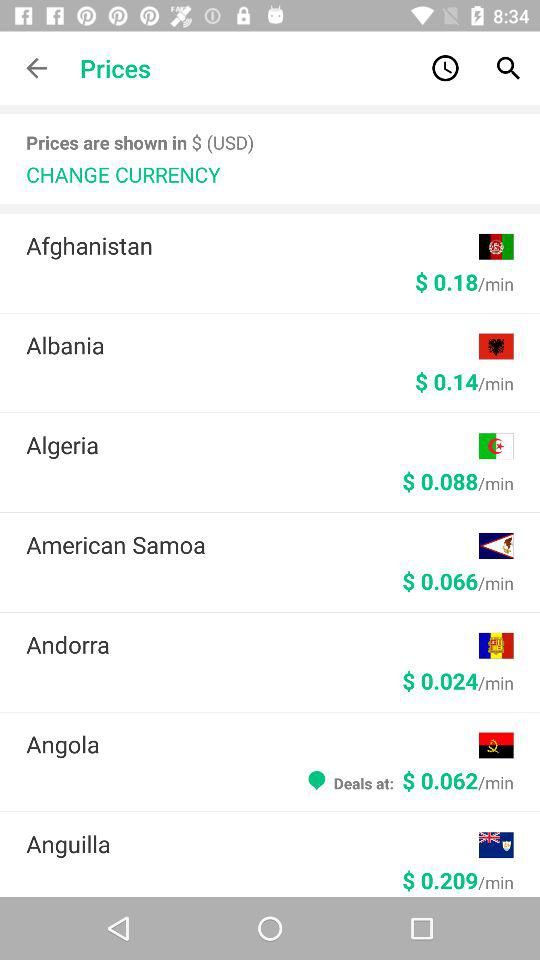How much does Algeria cost per minute?
Answer the question using a single word or phrase. Algeria costs $0.088/min. 